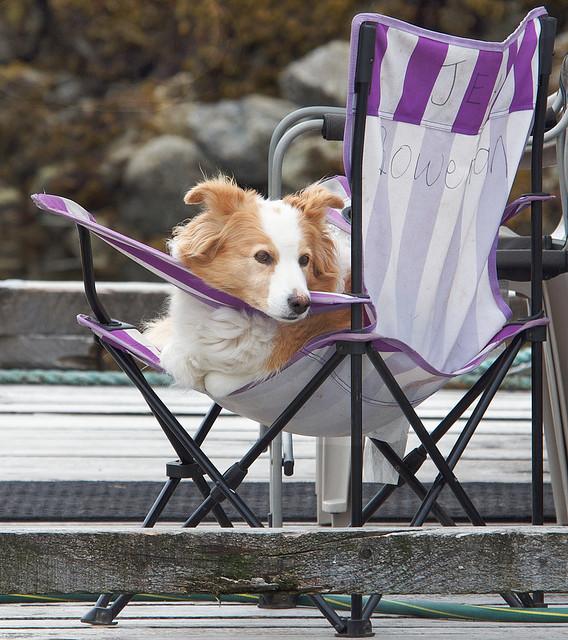Is the dog alert?
Short answer required. Yes. What breed of dog is this?
Be succinct. Collie. Where is the dog sitting?
Keep it brief. Chair. 